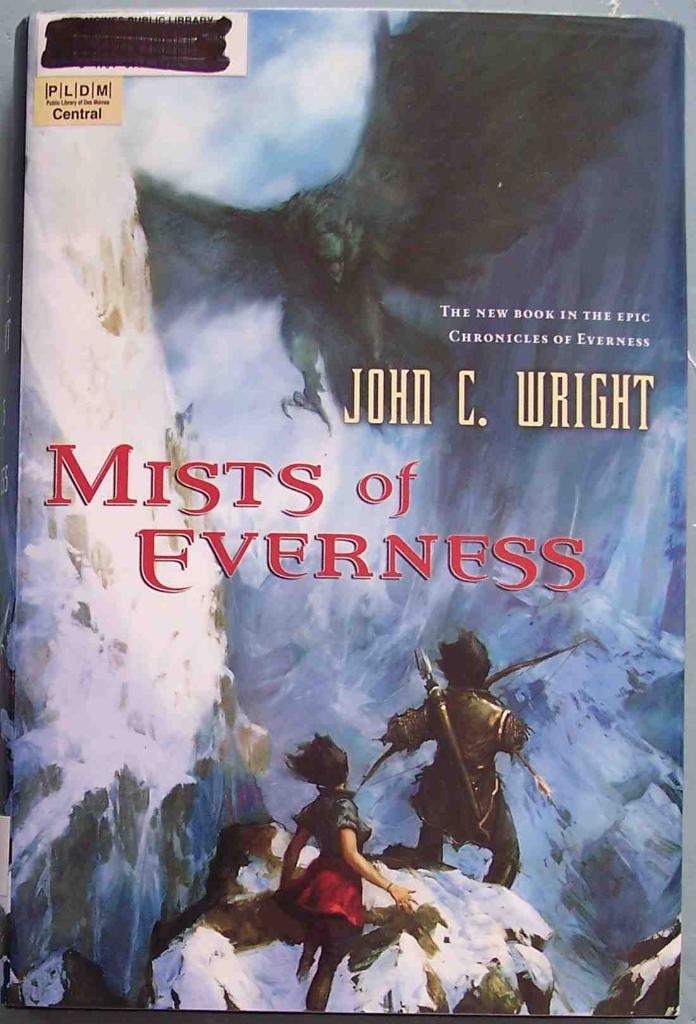<image>
Render a clear and concise summary of the photo. a book that is called Mists of Everness 